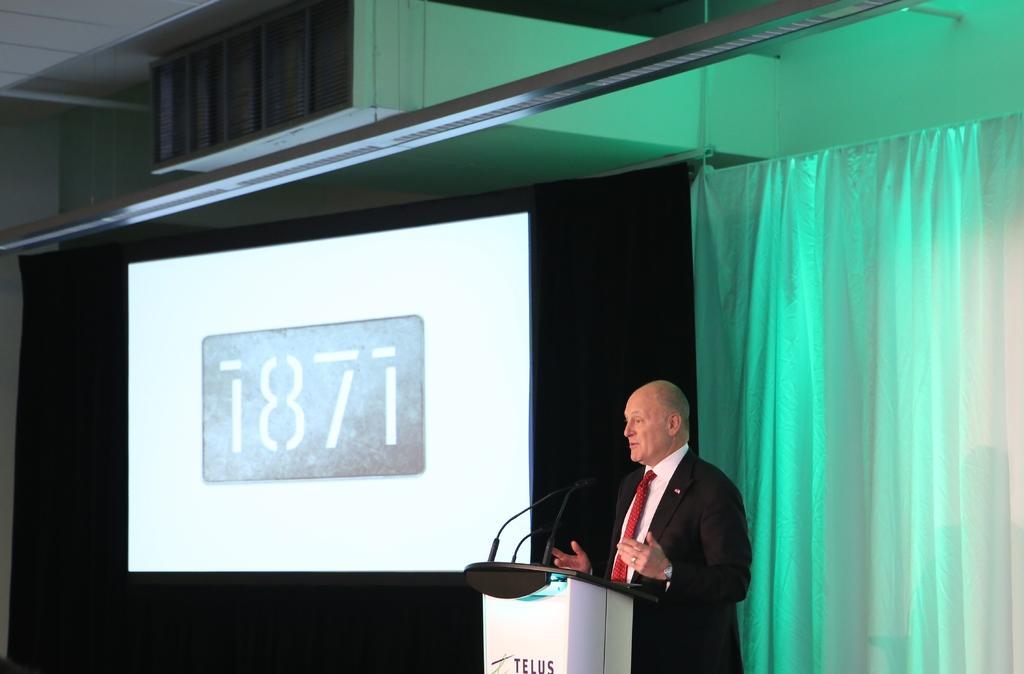Can you describe this image briefly? On the right a man is standing at the podium and on the podium we can see microphones. In the background we can see screen,curtain,wall and other objects. 